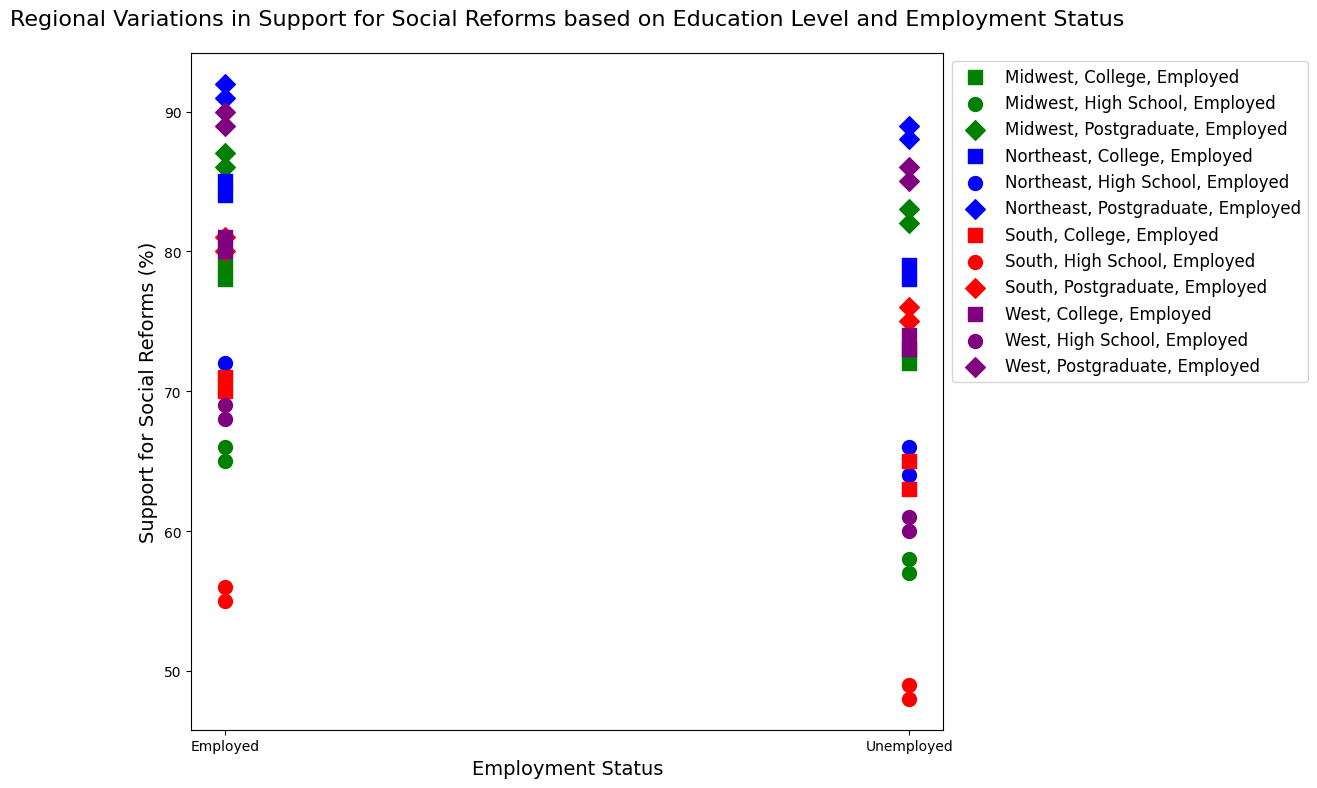What region and education level have the highest support for social reforms when employed? To find this, look for the scatter point representing the highest value on the y-axis among all employed categories. The postgraduate education level in the Northeast region has the highest support percentage at around 91 and 92.
Answer: Northeast, Postgraduate Which region shows the least support for social reforms from the unemployed individuals with a high school education? Identify the scatter point with the lowest value on the y-axis for unemployed high school categories. The South region shows the least support with a percentage around 48 and 49.
Answer: South Compare the average support for social reforms among employed individuals with a college education across all regions. Which region has the highest average? Calculate the average support for each region by summing the support percentages for employed college graduates and dividing by the count (two data points each). Comparisons are:
- Northeast: (85 + 84)/2 = 84.5
- South: (70 + 71)/2 = 70.5
- Midwest: (78 + 79)/2 = 78.5
- West: (80 + 81)/2 = 80.5
The highest average is in the Northeast region.
Answer: Northeast Which region demonstrates equal support for social reforms among unemployed college graduates, and what is this value? Look for scatter points that show the same y-axis value for unemployed college graduates. The West region values are 73 and 74. Here "equal" means approximate equality in practice.
Answer: West, approximately 73-74 Are employed or unemployed individuals with postgraduate education more supportive of social reforms in the Midwest, and by how much? Compare the average values for employed and unemployed postgraduate categories in the Midwest.
Employed: (86 + 87)/2 = 86.5
Unemployed: (82 + 83)/2 = 82.5
The employed individuals' support is 86.5, higher than the unemployed by 86.5 - 82.5 = 4.
Answer: Employed by 4 What is the difference in support for social reforms between employed high school graduates in the South and the West? Compare the scatter points for employed high school graduates in the South and West.
South (employed): (55 + 56)/2 = 55.5
West (employed): (68 + 69)/2 = 68.5
The difference is 68.5 - 55.5 = 13.
Answer: West supports 13% more Which region's unemployed individuals with a college education have more consistent support for social reforms? Assess the spread of values for each region's scatter points for unemployed college graduates, checking how close they are to each other:
- Northeast: 78, 79 (difference of 1)
- South: 63, 65 (difference of 2)
- Midwest: 72, 73 (difference of 1)
- West: 73, 74 (difference of 1)
Northeast, Midwest, and West regions have consistent support values, 1 percentage point apart. So, they equally share consistency.
Answer: Northeast, Midwest, and West (tie) Between employed and unemployed individuals with high school education, who shows greater support for social reforms in the Northeast? Compare the scatter points for employed and unemployed individuals with high school education.
Northeast (employed): 72, 70 (average 71)
Northeast (unemployed): 64, 66 (average 65)
Employed individuals show greater support (71 to 65).
Answer: Employed by 6 